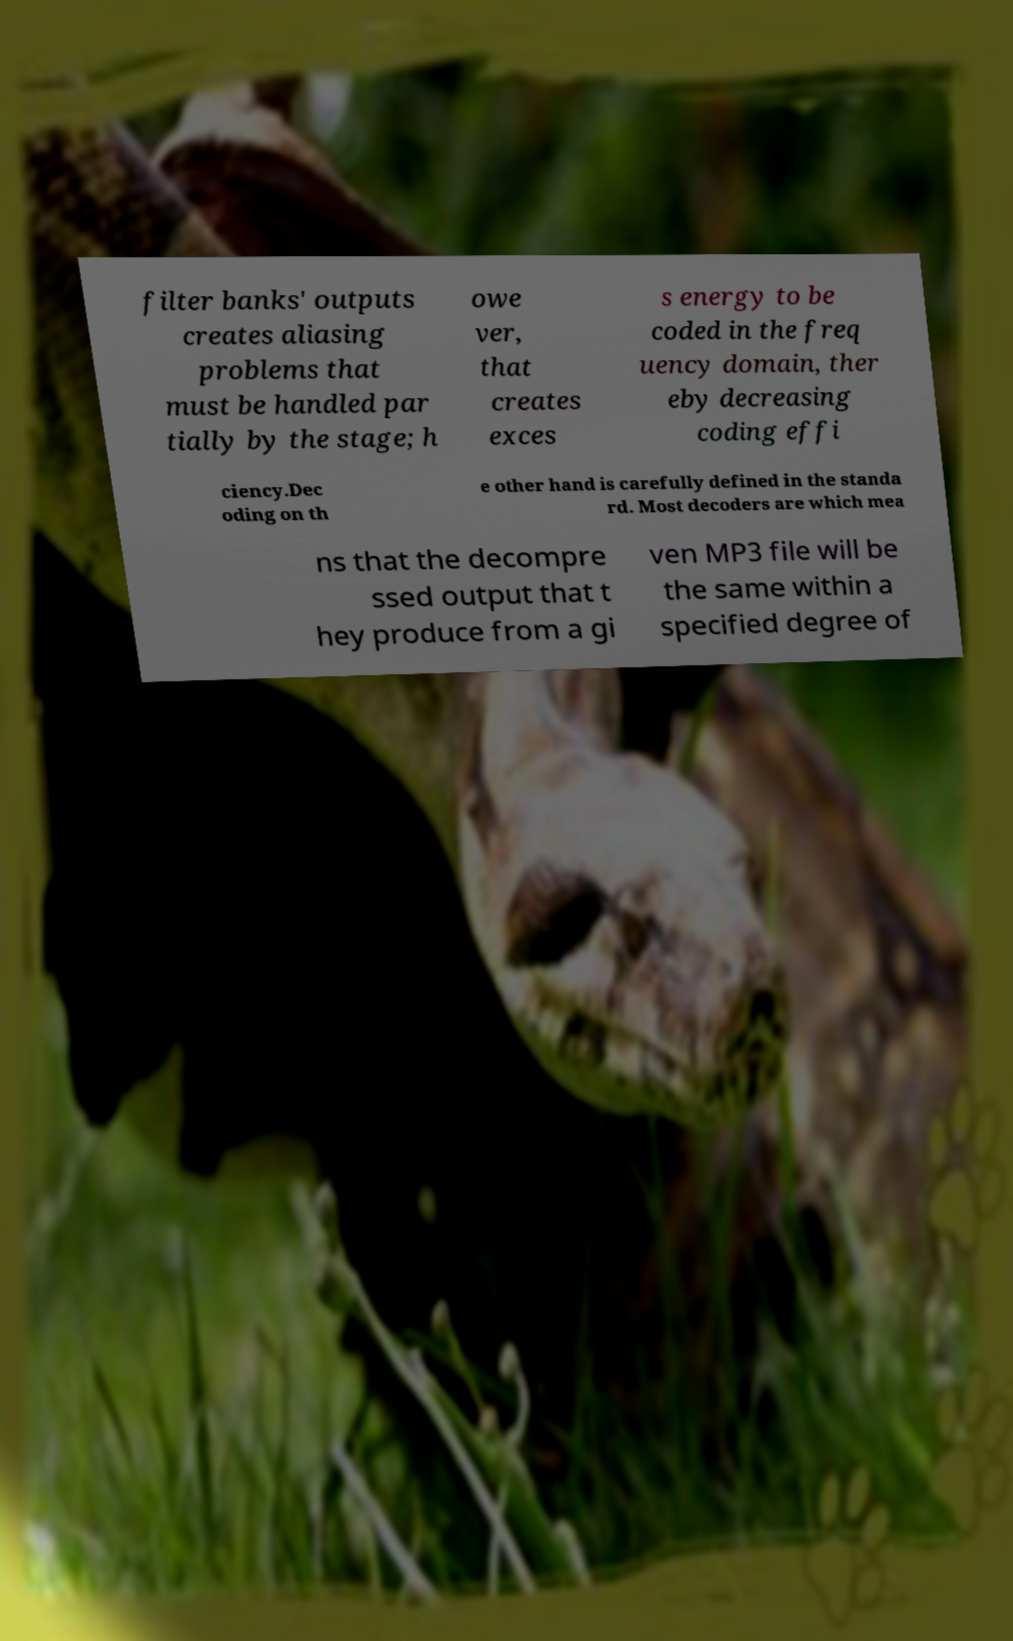Could you extract and type out the text from this image? filter banks' outputs creates aliasing problems that must be handled par tially by the stage; h owe ver, that creates exces s energy to be coded in the freq uency domain, ther eby decreasing coding effi ciency.Dec oding on th e other hand is carefully defined in the standa rd. Most decoders are which mea ns that the decompre ssed output that t hey produce from a gi ven MP3 file will be the same within a specified degree of 